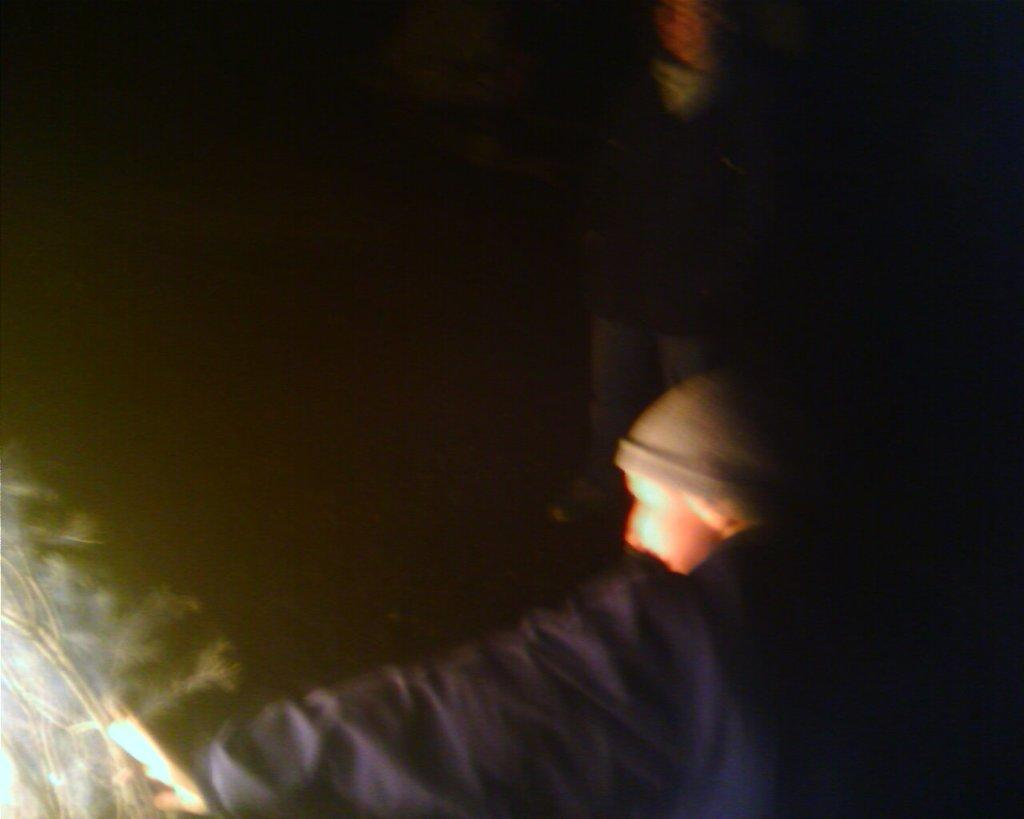Who or what is the main subject of the image? There is a person in the image. Can you describe the background of the image? The background of the image is dark. What type of pencil is the person using in the image? There is no pencil present in the image. Is the person taking a bath in the image? There is no indication of a bath or any water-related activity in the image. 